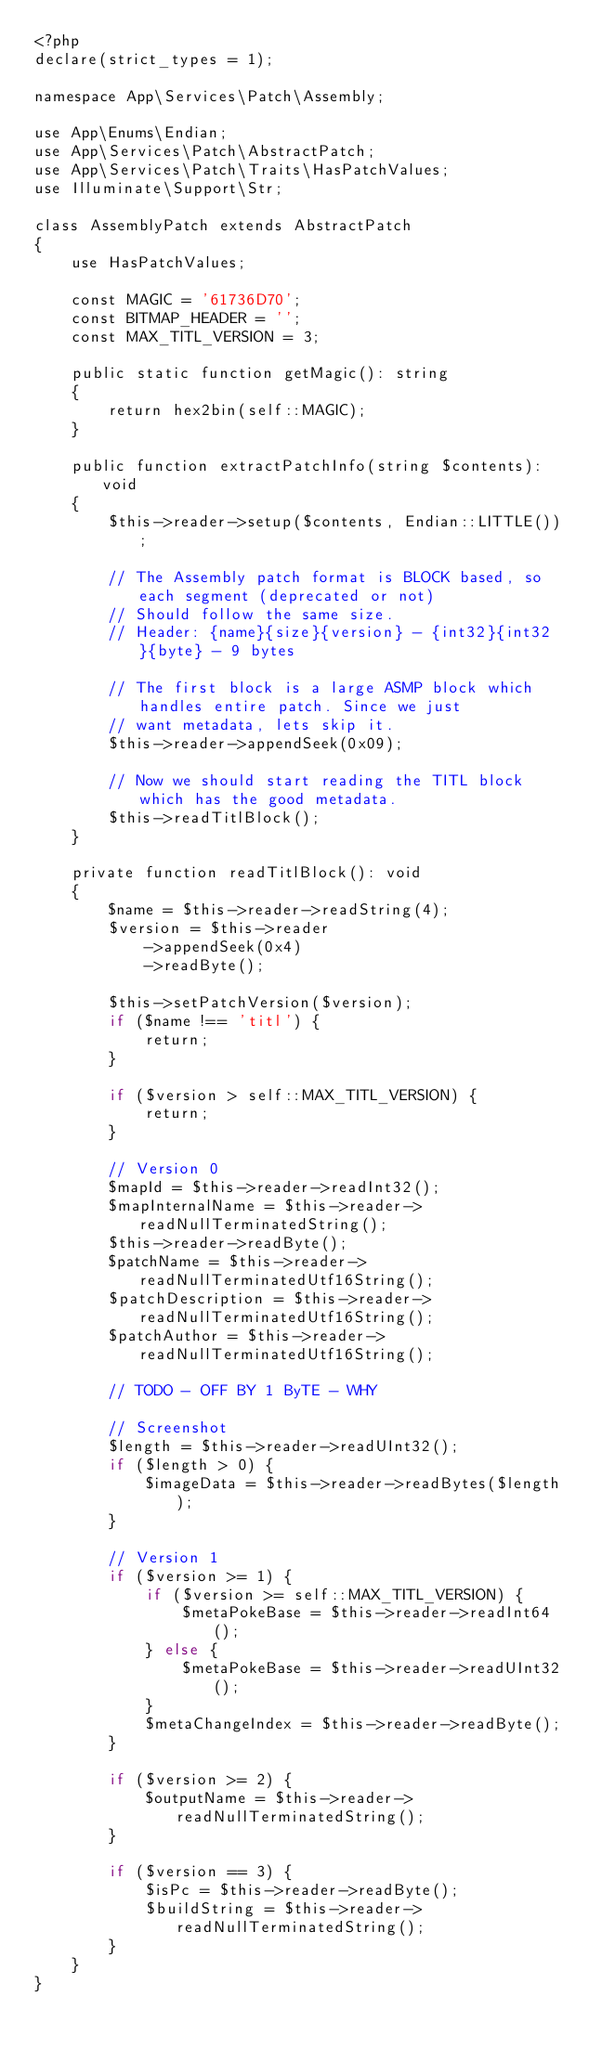<code> <loc_0><loc_0><loc_500><loc_500><_PHP_><?php
declare(strict_types = 1);

namespace App\Services\Patch\Assembly;

use App\Enums\Endian;
use App\Services\Patch\AbstractPatch;
use App\Services\Patch\Traits\HasPatchValues;
use Illuminate\Support\Str;

class AssemblyPatch extends AbstractPatch
{
    use HasPatchValues;

    const MAGIC = '61736D70';
    const BITMAP_HEADER = '';
    const MAX_TITL_VERSION = 3;

    public static function getMagic(): string
    {
        return hex2bin(self::MAGIC);
    }

    public function extractPatchInfo(string $contents): void
    {
        $this->reader->setup($contents, Endian::LITTLE());

        // The Assembly patch format is BLOCK based, so each segment (deprecated or not)
        // Should follow the same size.
        // Header: {name}{size}{version} - {int32}{int32}{byte} - 9 bytes

        // The first block is a large ASMP block which handles entire patch. Since we just
        // want metadata, lets skip it.
        $this->reader->appendSeek(0x09);

        // Now we should start reading the TITL block which has the good metadata.
        $this->readTitlBlock();
    }

    private function readTitlBlock(): void
    {
        $name = $this->reader->readString(4);
        $version = $this->reader
            ->appendSeek(0x4)
            ->readByte();

        $this->setPatchVersion($version);
        if ($name !== 'titl') {
            return;
        }

        if ($version > self::MAX_TITL_VERSION) {
            return;
        }

        // Version 0
        $mapId = $this->reader->readInt32();
        $mapInternalName = $this->reader->readNullTerminatedString();
        $this->reader->readByte();
        $patchName = $this->reader->readNullTerminatedUtf16String();
        $patchDescription = $this->reader->readNullTerminatedUtf16String();
        $patchAuthor = $this->reader->readNullTerminatedUtf16String();

        // TODO - OFF BY 1 ByTE - WHY

        // Screenshot
        $length = $this->reader->readUInt32();
        if ($length > 0) {
            $imageData = $this->reader->readBytes($length);
        }

        // Version 1
        if ($version >= 1) {
            if ($version >= self::MAX_TITL_VERSION) {
                $metaPokeBase = $this->reader->readInt64();
            } else {
                $metaPokeBase = $this->reader->readUInt32();
            }
            $metaChangeIndex = $this->reader->readByte();
        }

        if ($version >= 2) {
            $outputName = $this->reader->readNullTerminatedString();
        }

        if ($version == 3) {
            $isPc = $this->reader->readByte();
            $buildString = $this->reader->readNullTerminatedString();
        }
    }
}
</code> 